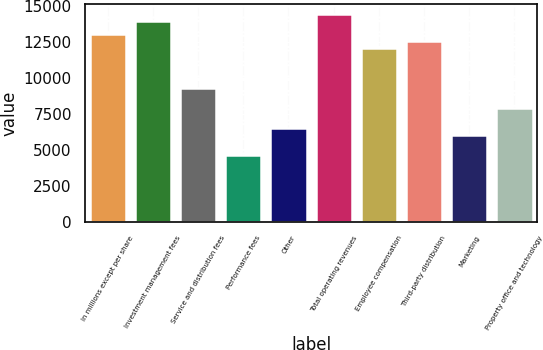Convert chart to OTSL. <chart><loc_0><loc_0><loc_500><loc_500><bar_chart><fcel>in millions except per share<fcel>Investment management fees<fcel>Service and distribution fees<fcel>Performance fees<fcel>Other<fcel>Total operating revenues<fcel>Employee compensation<fcel>Third-party distribution<fcel>Marketing<fcel>Property office and technology<nl><fcel>13004.7<fcel>13933.6<fcel>9289.14<fcel>4644.64<fcel>6502.44<fcel>14398.1<fcel>12075.8<fcel>12540.3<fcel>6037.99<fcel>7895.79<nl></chart> 